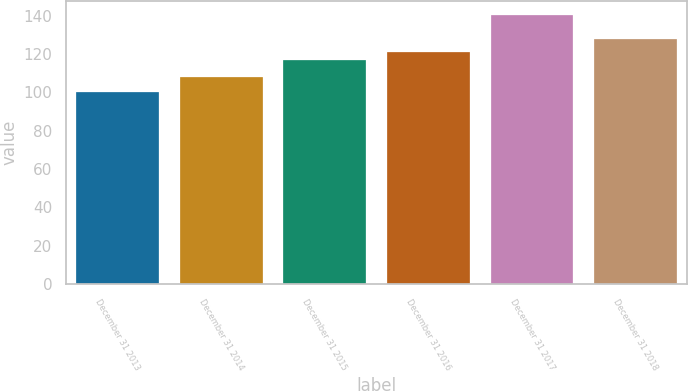Convert chart. <chart><loc_0><loc_0><loc_500><loc_500><bar_chart><fcel>December 31 2013<fcel>December 31 2014<fcel>December 31 2015<fcel>December 31 2016<fcel>December 31 2017<fcel>December 31 2018<nl><fcel>100<fcel>107.8<fcel>116.8<fcel>120.85<fcel>140.5<fcel>127.7<nl></chart> 